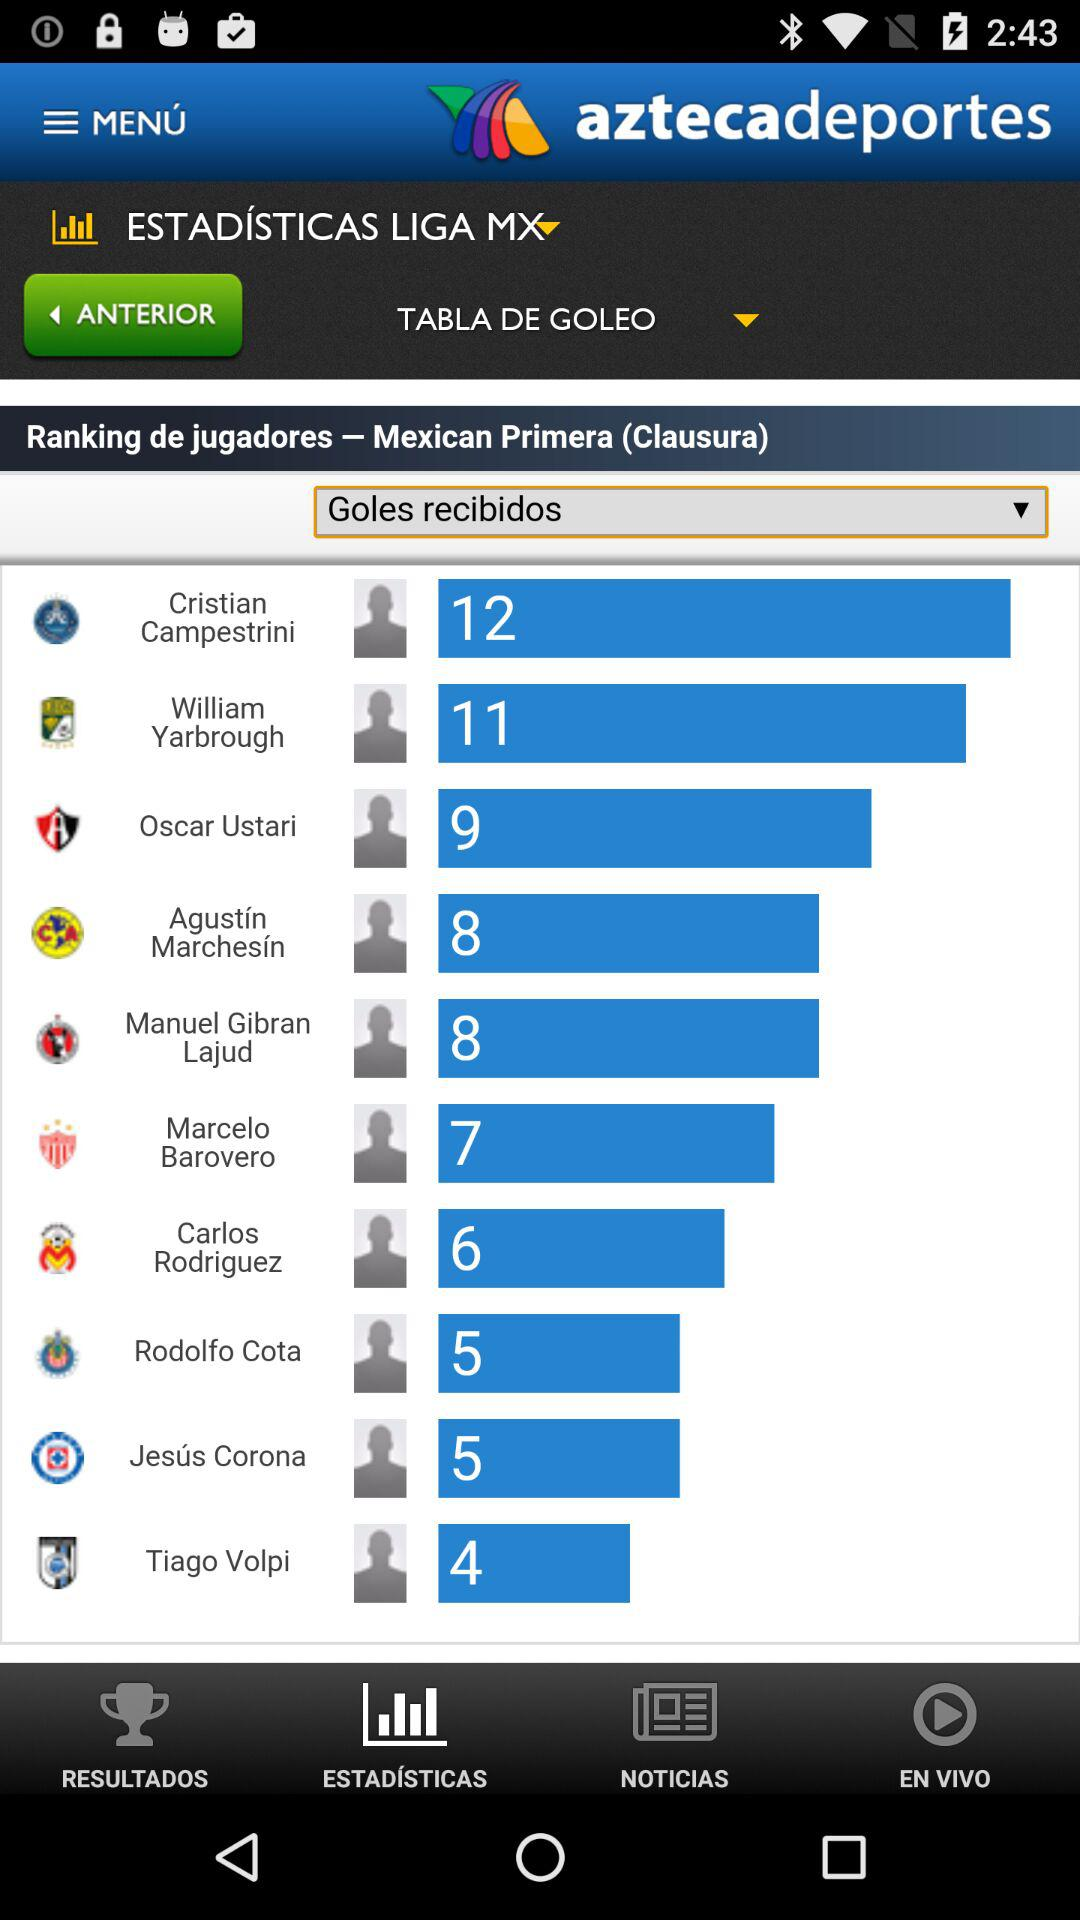How many more goals does Cristian Campestini have than William Yarbrough?
Answer the question using a single word or phrase. 1 